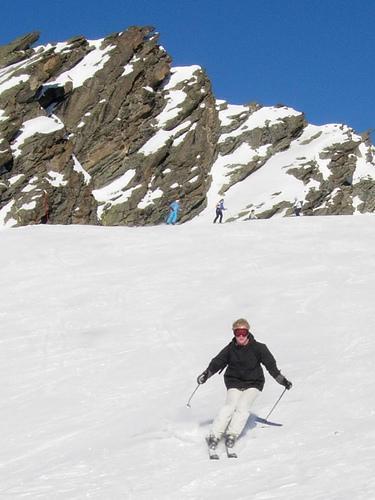How many women are there?
Give a very brief answer. 1. How many people are at the top of the slope?
Give a very brief answer. 2. 